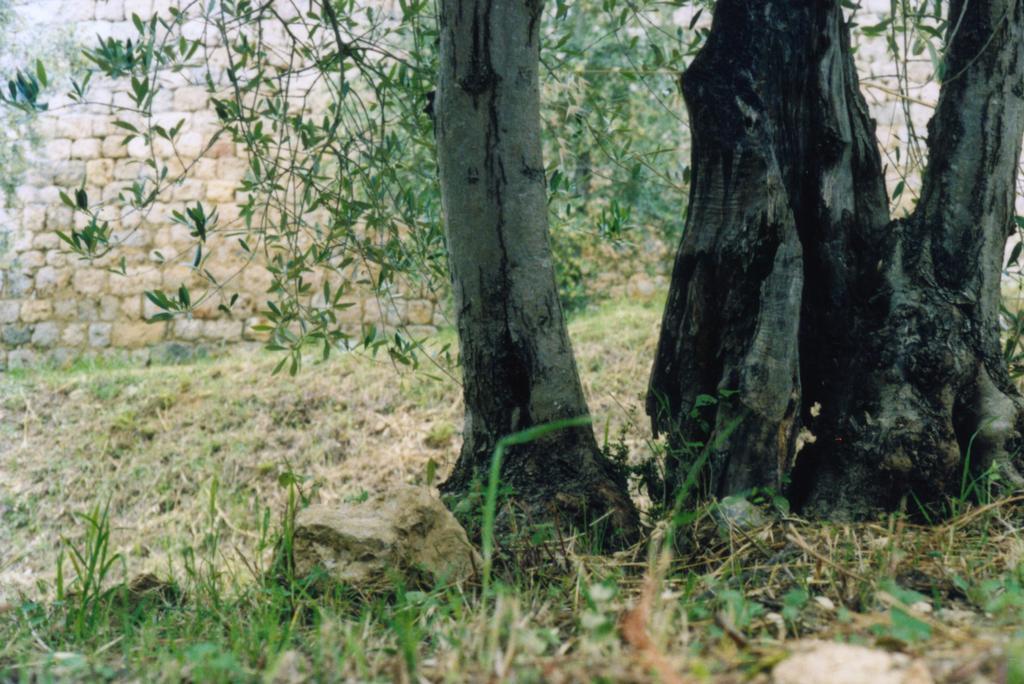Please provide a concise description of this image. In this image, we can see trees. In the background, there is a wall and at the bottom, there is grass and rocks on the ground. 